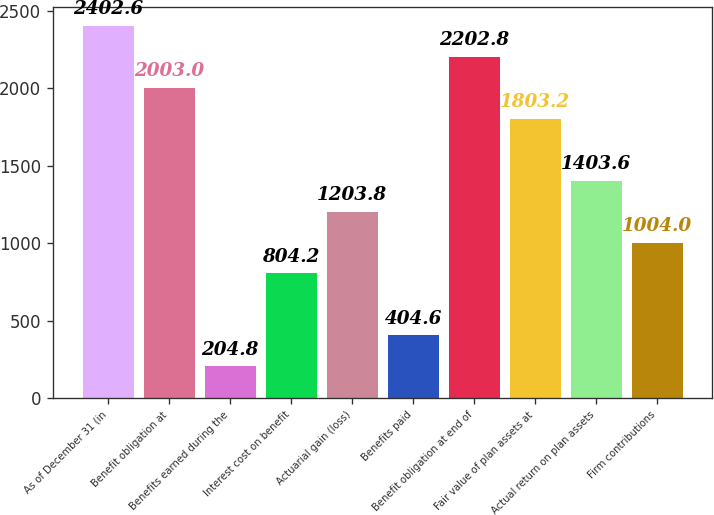Convert chart. <chart><loc_0><loc_0><loc_500><loc_500><bar_chart><fcel>As of December 31 (in<fcel>Benefit obligation at<fcel>Benefits earned during the<fcel>Interest cost on benefit<fcel>Actuarial gain (loss)<fcel>Benefits paid<fcel>Benefit obligation at end of<fcel>Fair value of plan assets at<fcel>Actual return on plan assets<fcel>Firm contributions<nl><fcel>2402.6<fcel>2003<fcel>204.8<fcel>804.2<fcel>1203.8<fcel>404.6<fcel>2202.8<fcel>1803.2<fcel>1403.6<fcel>1004<nl></chart> 